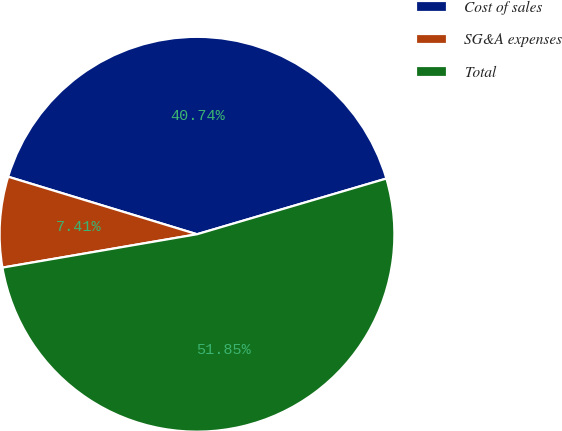Convert chart. <chart><loc_0><loc_0><loc_500><loc_500><pie_chart><fcel>Cost of sales<fcel>SG&A expenses<fcel>Total<nl><fcel>40.74%<fcel>7.41%<fcel>51.85%<nl></chart> 